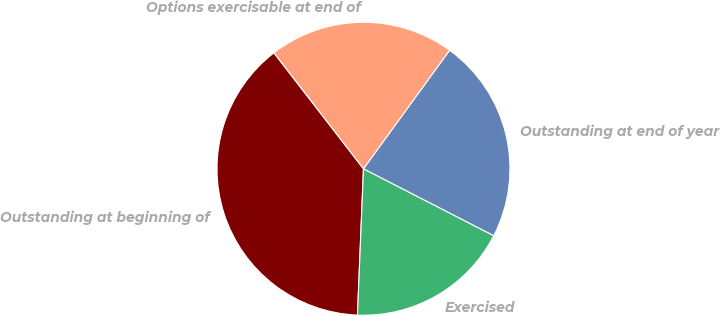<chart> <loc_0><loc_0><loc_500><loc_500><pie_chart><fcel>Outstanding at beginning of<fcel>Exercised<fcel>Outstanding at end of year<fcel>Options exercisable at end of<nl><fcel>38.88%<fcel>18.1%<fcel>22.55%<fcel>20.47%<nl></chart> 